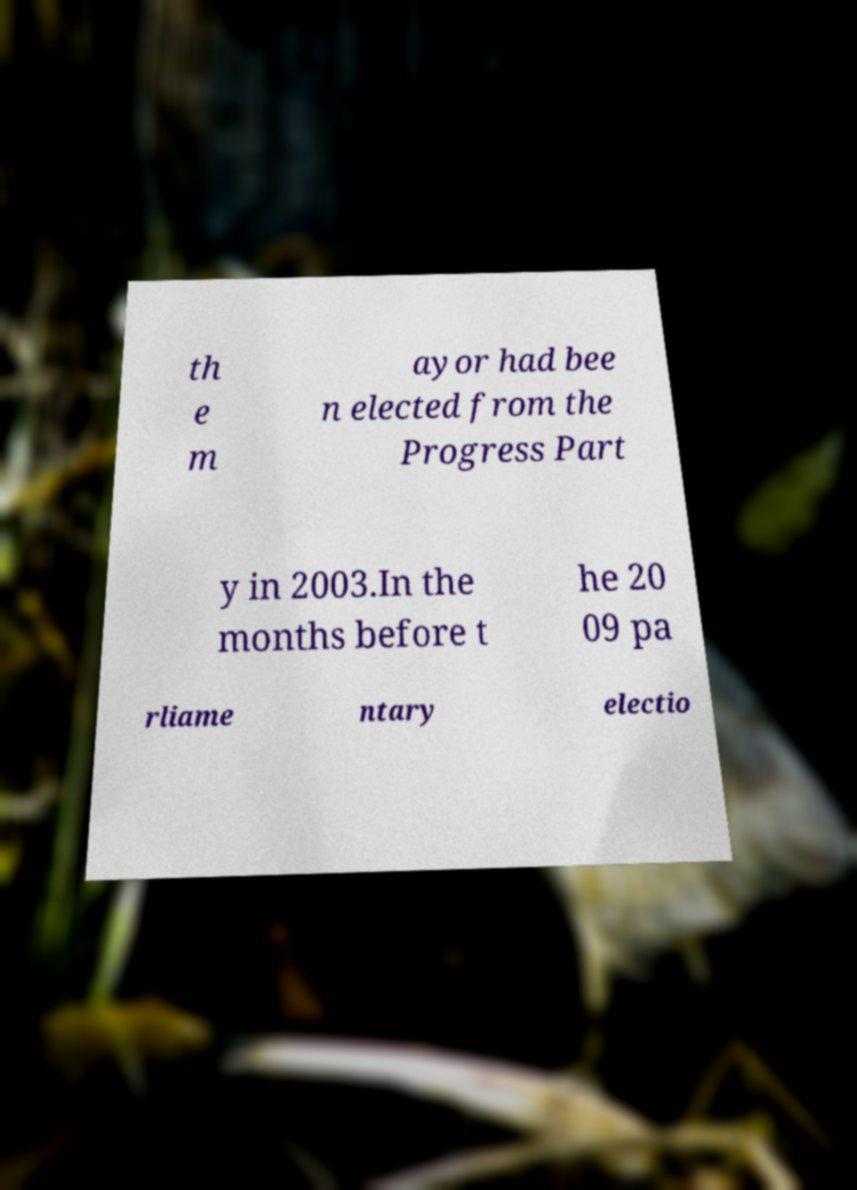Can you accurately transcribe the text from the provided image for me? th e m ayor had bee n elected from the Progress Part y in 2003.In the months before t he 20 09 pa rliame ntary electio 